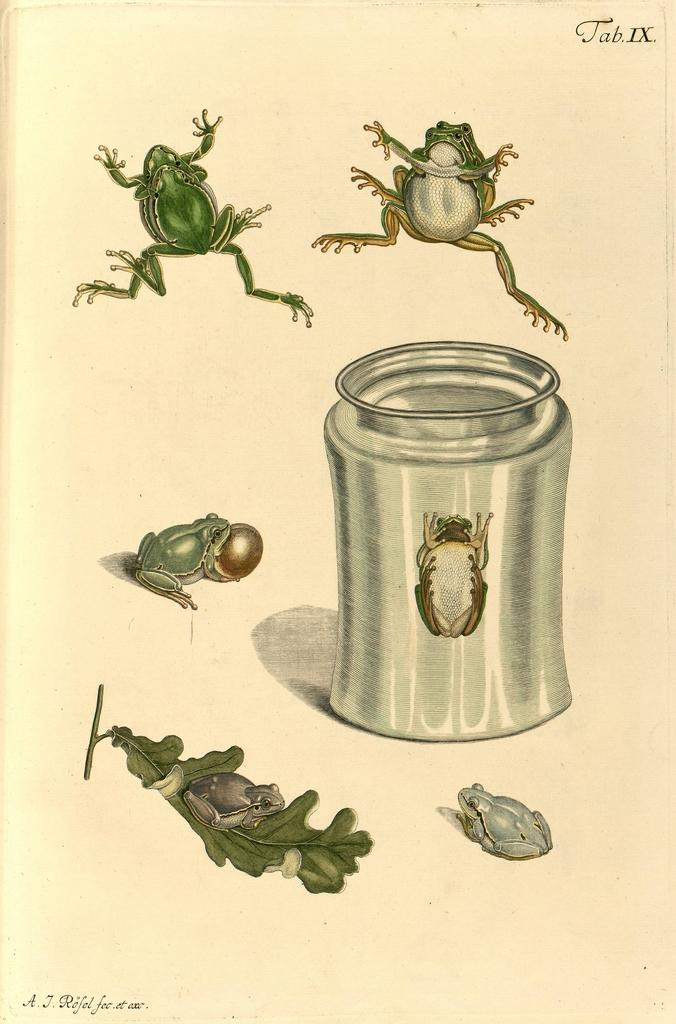What is depicted on the paper in the image? The paper contains paintings of frogs and a leaf. What else can be seen in the image besides the paper? There is a jar in the image, and an insect is inside the jar. What type of whip is hanging from the leaf in the image? There is no whip present in the image; the paper contains paintings of frogs and a leaf, but no whip. Can you tell me how many beans are in the jar with the insect? There is no mention of beans in the image; the jar contains an insect, but no beans. 